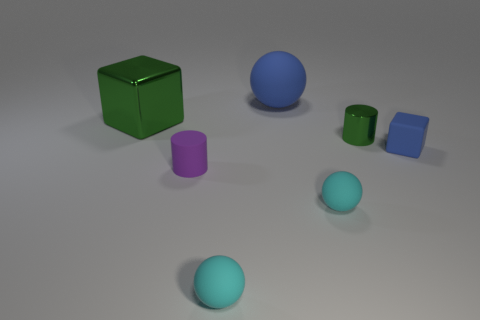Are there an equal number of rubber spheres that are right of the blue cube and yellow metal spheres?
Offer a terse response. Yes. There is a green metal object that is on the right side of the big block; what size is it?
Your answer should be compact. Small. How many small cyan objects are the same shape as the small purple rubber thing?
Ensure brevity in your answer.  0. The tiny thing that is both behind the purple rubber cylinder and on the left side of the tiny blue object is made of what material?
Provide a succinct answer. Metal. Are the small blue cube and the tiny green object made of the same material?
Ensure brevity in your answer.  No. What number of big shiny blocks are there?
Offer a terse response. 1. There is a matte thing to the left of the rubber ball that is on the left side of the matte thing that is behind the rubber block; what color is it?
Provide a succinct answer. Purple. Does the tiny matte cylinder have the same color as the shiny cube?
Ensure brevity in your answer.  No. What number of small matte things are both behind the purple cylinder and in front of the tiny blue matte cube?
Ensure brevity in your answer.  0. How many matte objects are either green cylinders or tiny purple spheres?
Give a very brief answer. 0. 